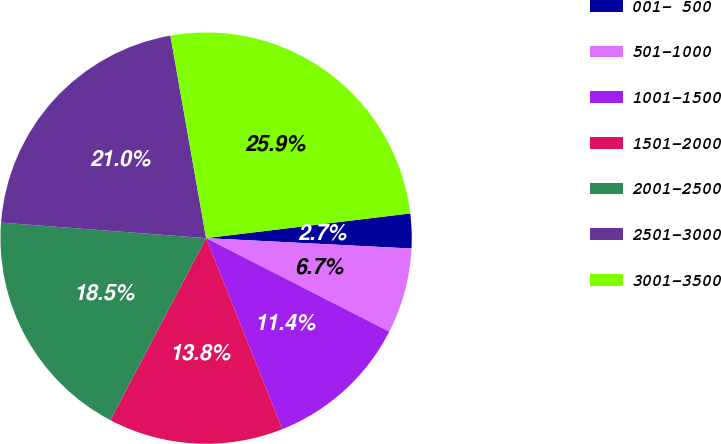Convert chart to OTSL. <chart><loc_0><loc_0><loc_500><loc_500><pie_chart><fcel>001- 500<fcel>501-1000<fcel>1001-1500<fcel>1501-2000<fcel>2001-2500<fcel>2501-3000<fcel>3001-3500<nl><fcel>2.72%<fcel>6.71%<fcel>11.44%<fcel>13.76%<fcel>18.49%<fcel>21.02%<fcel>25.86%<nl></chart> 